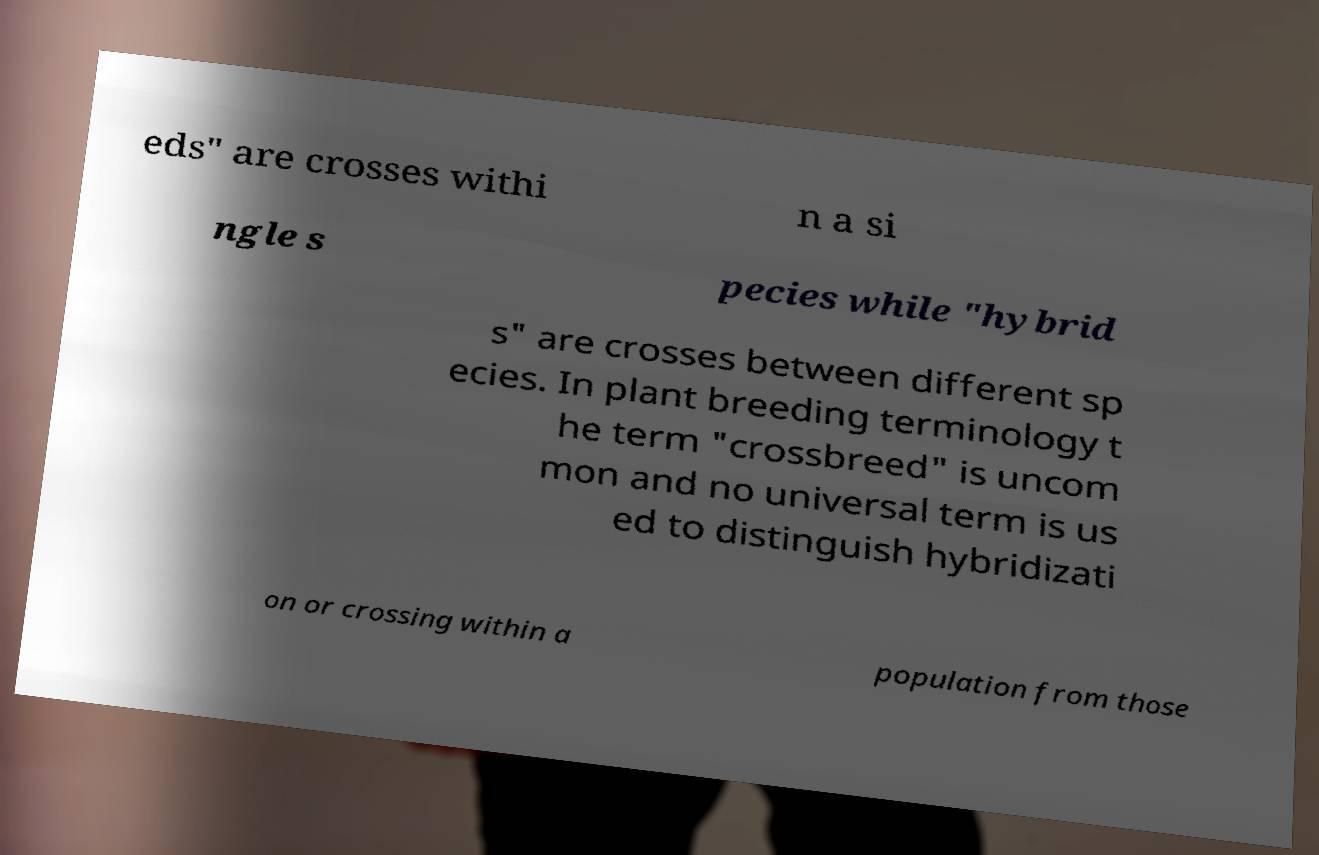What messages or text are displayed in this image? I need them in a readable, typed format. eds" are crosses withi n a si ngle s pecies while "hybrid s" are crosses between different sp ecies. In plant breeding terminology t he term "crossbreed" is uncom mon and no universal term is us ed to distinguish hybridizati on or crossing within a population from those 